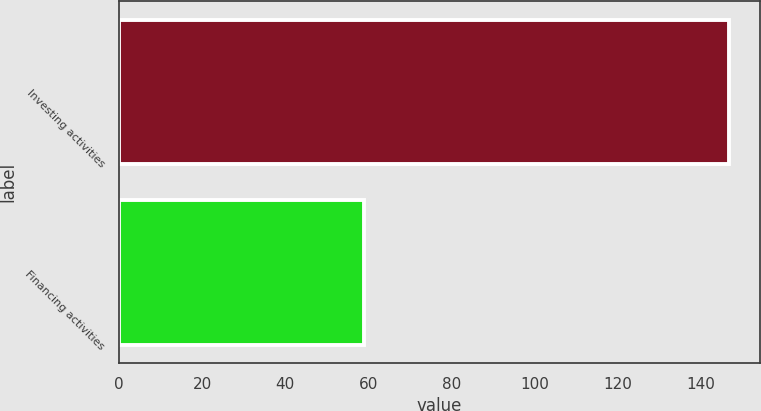Convert chart. <chart><loc_0><loc_0><loc_500><loc_500><bar_chart><fcel>Investing activities<fcel>Financing activities<nl><fcel>147<fcel>59<nl></chart> 